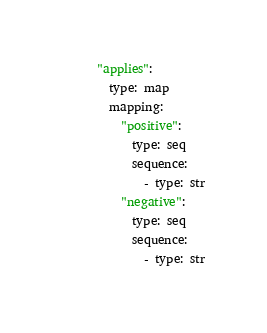<code> <loc_0><loc_0><loc_500><loc_500><_YAML_>      "applies":
        type: map
        mapping:
          "positive":
            type: seq
            sequence:
              - type: str
          "negative":
            type: seq
            sequence:
              - type: str</code> 